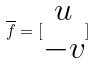Convert formula to latex. <formula><loc_0><loc_0><loc_500><loc_500>\overline { f } = [ \begin{matrix} u \\ - v \end{matrix} ]</formula> 